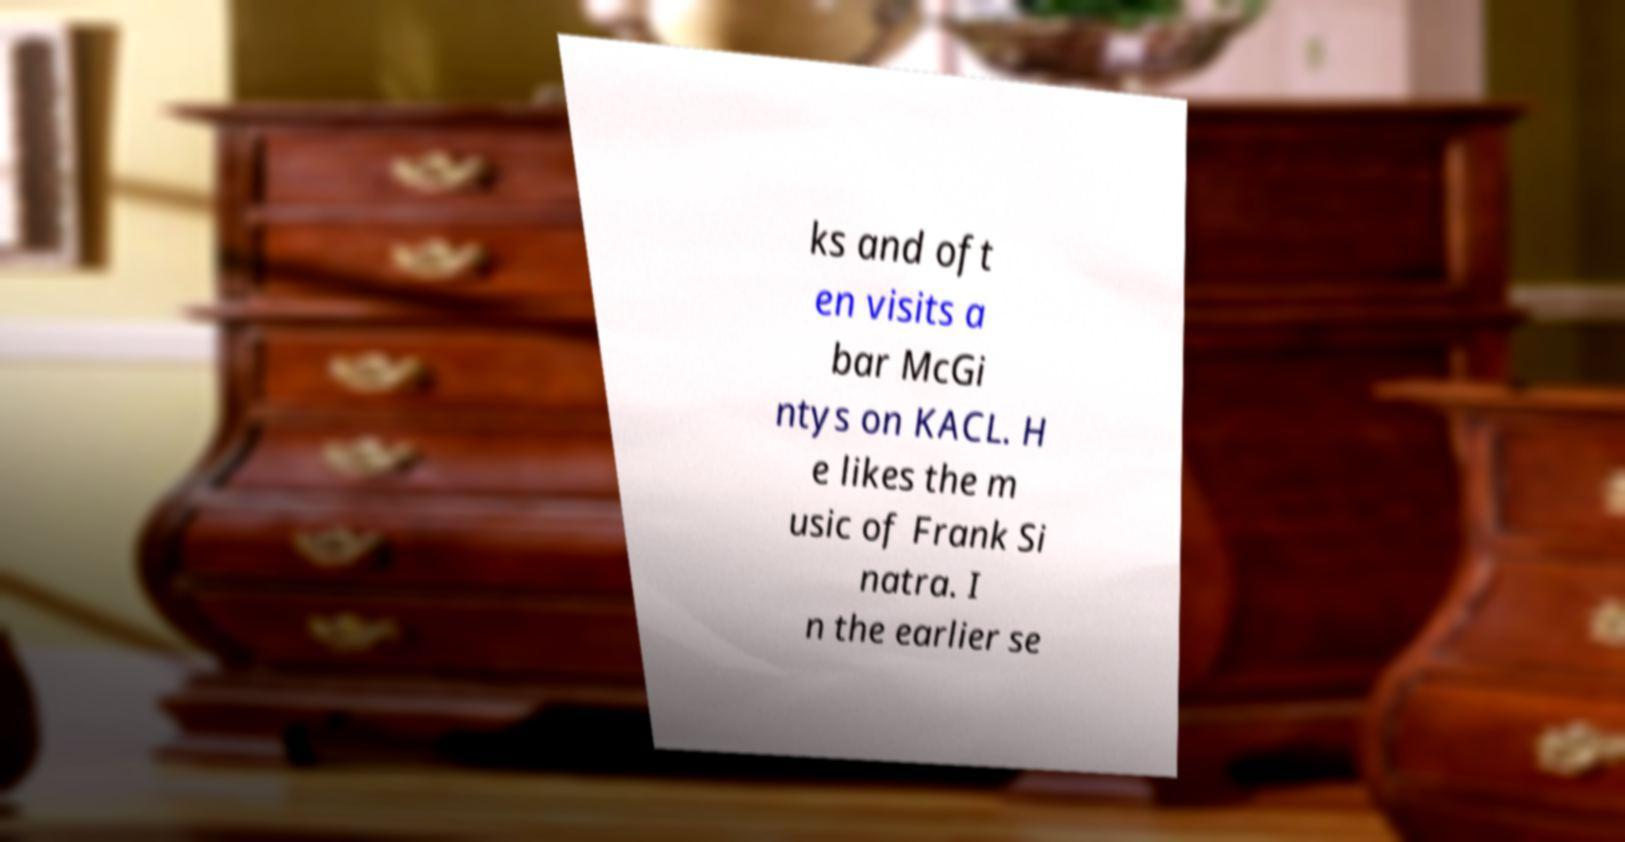There's text embedded in this image that I need extracted. Can you transcribe it verbatim? ks and oft en visits a bar McGi ntys on KACL. H e likes the m usic of Frank Si natra. I n the earlier se 